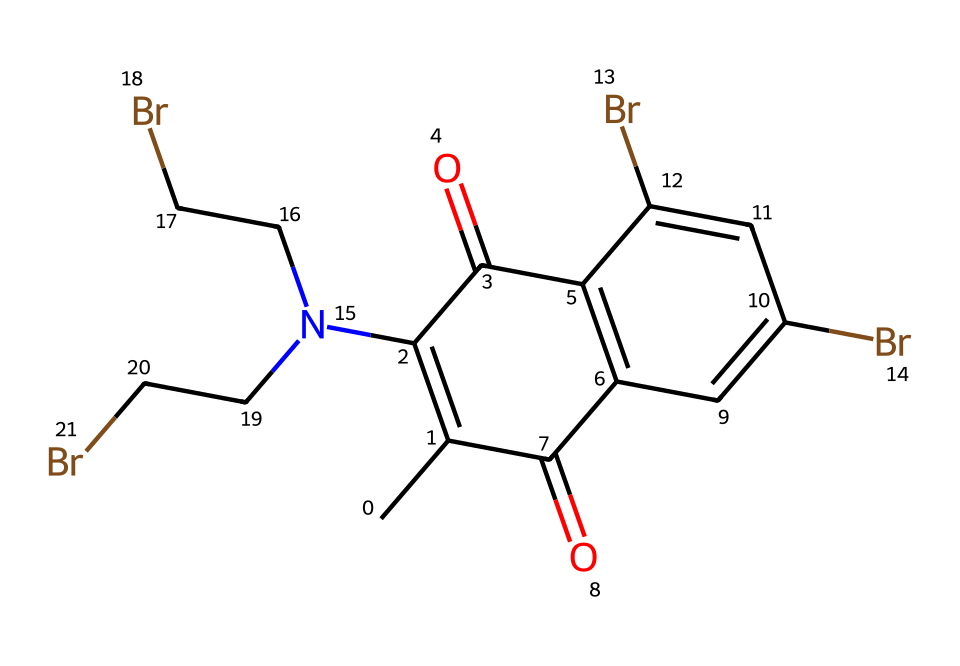What type of functional groups are present in this dye? The chemical structure contains both carbonyl (C=O) groups and bromine (Br) substituents. The presence of the carbonyl groups indicates the presence of ketone functionality, which is common in many dyes. Additionally, the bromine atoms suggest that this compound may have flame-retardant properties due to the halogen atoms' ability to interrupt combustion processes.
Answer: carbonyl and bromine How many bromine atoms are in the compound? By examining the SMILES representation, we find that there are three instances of "Br," indicating there are three bromine atoms in the chemical structure.
Answer: three What is the degree of unsaturation in this dye molecule? The degree of unsaturation can be calculated by counting the number of rings and double bonds. In this structure, there are two carbonyl groups (which provide double bonds) and several aromatic carbon-carbon double bonds, suggesting a total of four degrees of unsaturation. This is confirmed by analyzing the structure visually, which shows two rings (in the fused ring system) and multiple double bonds.
Answer: four How many nitrogen atoms are present in this chemical structure? The SMILES notation indicates one nitrogen atom (N) present in the structure, specifically part of an amine group. This can be verified by identifying the "N" within the representation, which denotes the single nitrogen in the compound.
Answer: one Is this dye likely to be soluble in water? Typically, dyes with significant hydrophobic (non-polar) components, like brominated or alkylated structures, tend to be less soluble in water. The presence of multiple bromine atoms and the extensive carbon framework hint at low water solubility. Therefore, based on structural reasoning and the nature of the substituents, it is reasonable to conclude it is likely to have low solubility.
Answer: low What properties could the bromine substituents impart to the dye? The bromine substituents can enhance flame-retardant properties by interfering with the combustion process, as bromine can act as a fire retardant due to its ability to form stable radicals that disrupt flame propagation. Additionally, they may contribute to the dye's overall stability and resistance to degradation under heat.
Answer: flame-retardant properties 